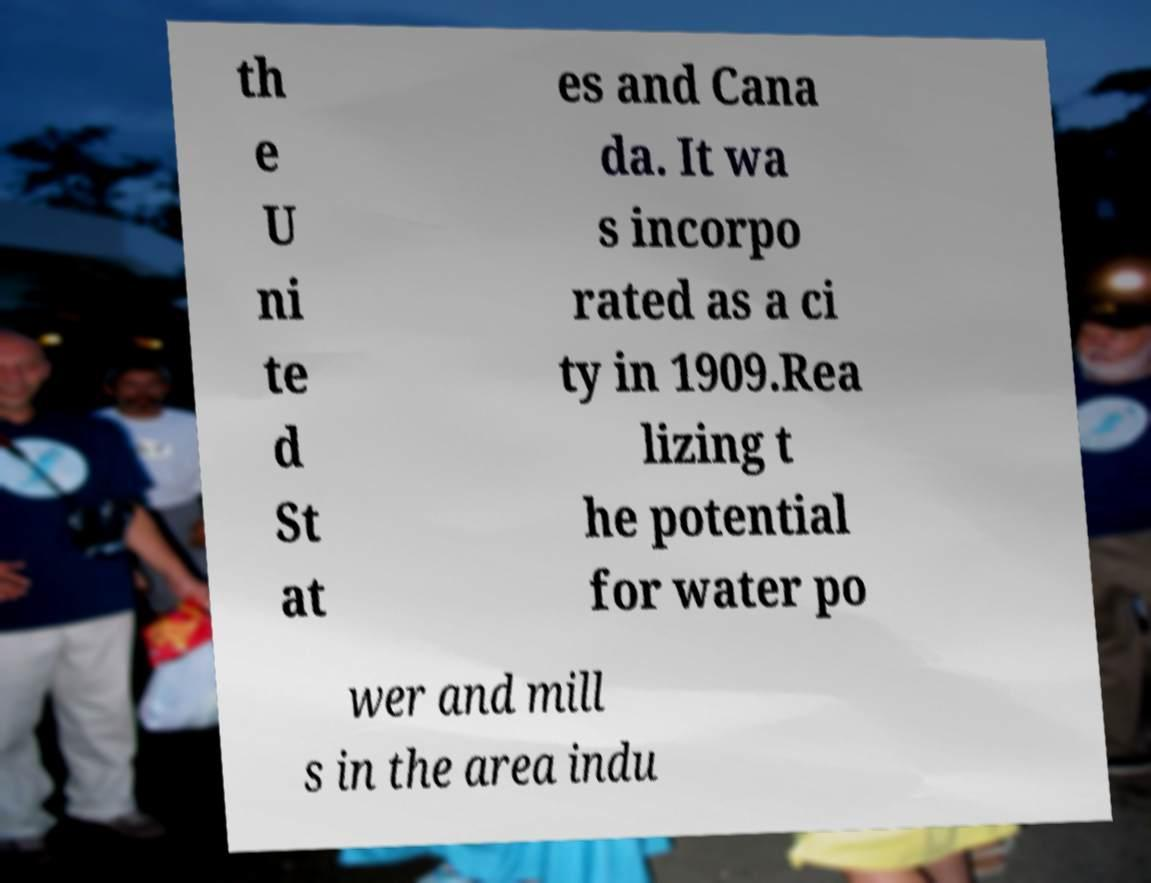Could you extract and type out the text from this image? th e U ni te d St at es and Cana da. It wa s incorpo rated as a ci ty in 1909.Rea lizing t he potential for water po wer and mill s in the area indu 